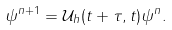Convert formula to latex. <formula><loc_0><loc_0><loc_500><loc_500>\psi ^ { n + 1 } = \mathcal { U } _ { h } ( t + \tau , t ) \psi ^ { n } .</formula> 